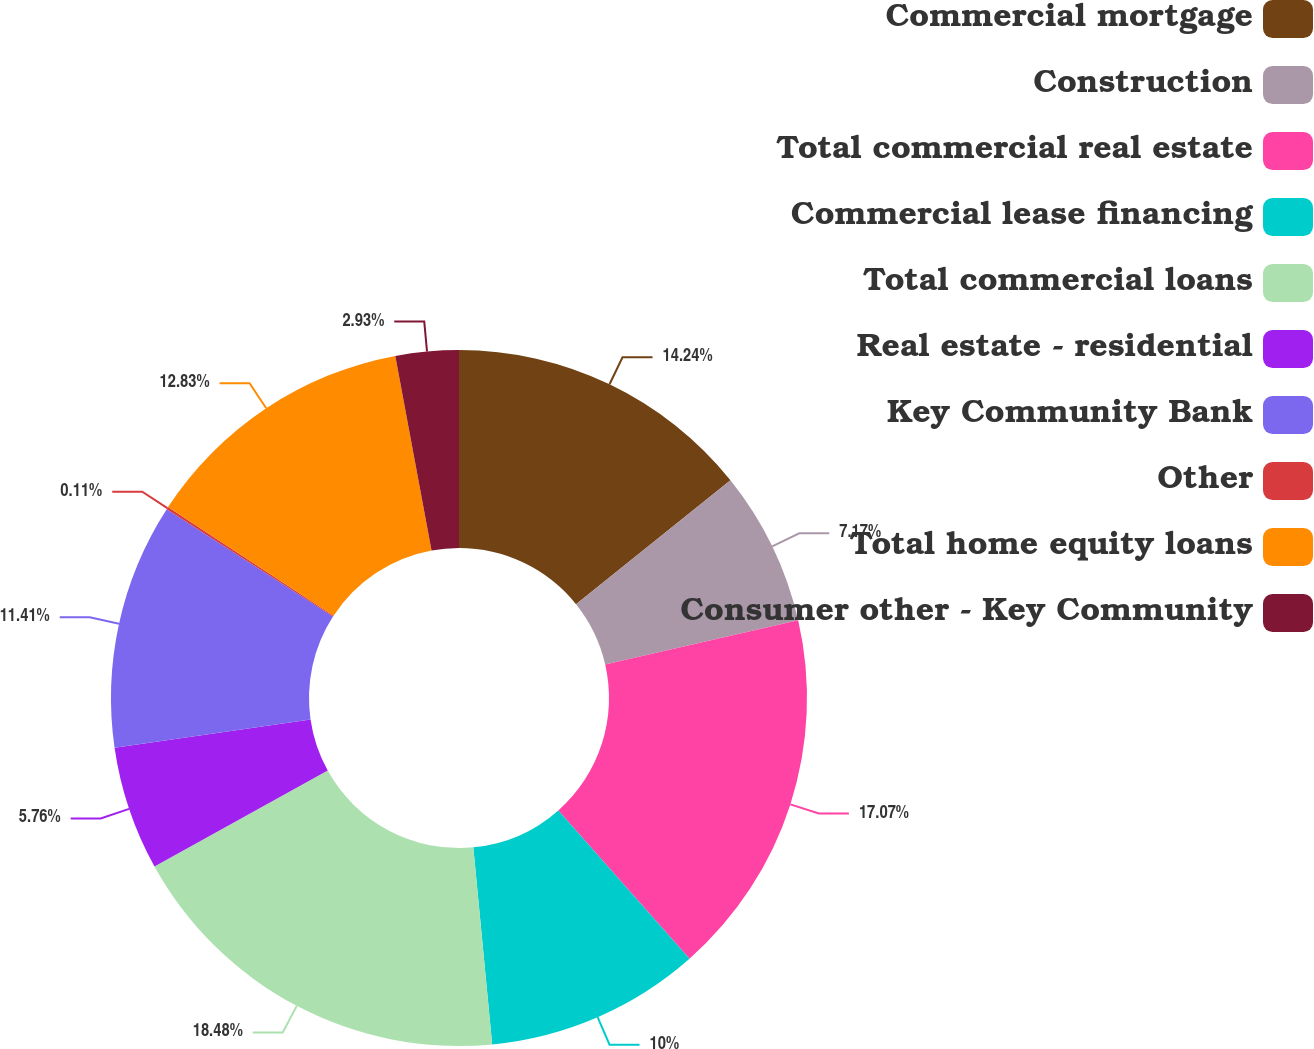<chart> <loc_0><loc_0><loc_500><loc_500><pie_chart><fcel>Commercial mortgage<fcel>Construction<fcel>Total commercial real estate<fcel>Commercial lease financing<fcel>Total commercial loans<fcel>Real estate - residential<fcel>Key Community Bank<fcel>Other<fcel>Total home equity loans<fcel>Consumer other - Key Community<nl><fcel>14.24%<fcel>7.17%<fcel>17.07%<fcel>10.0%<fcel>18.48%<fcel>5.76%<fcel>11.41%<fcel>0.11%<fcel>12.83%<fcel>2.93%<nl></chart> 